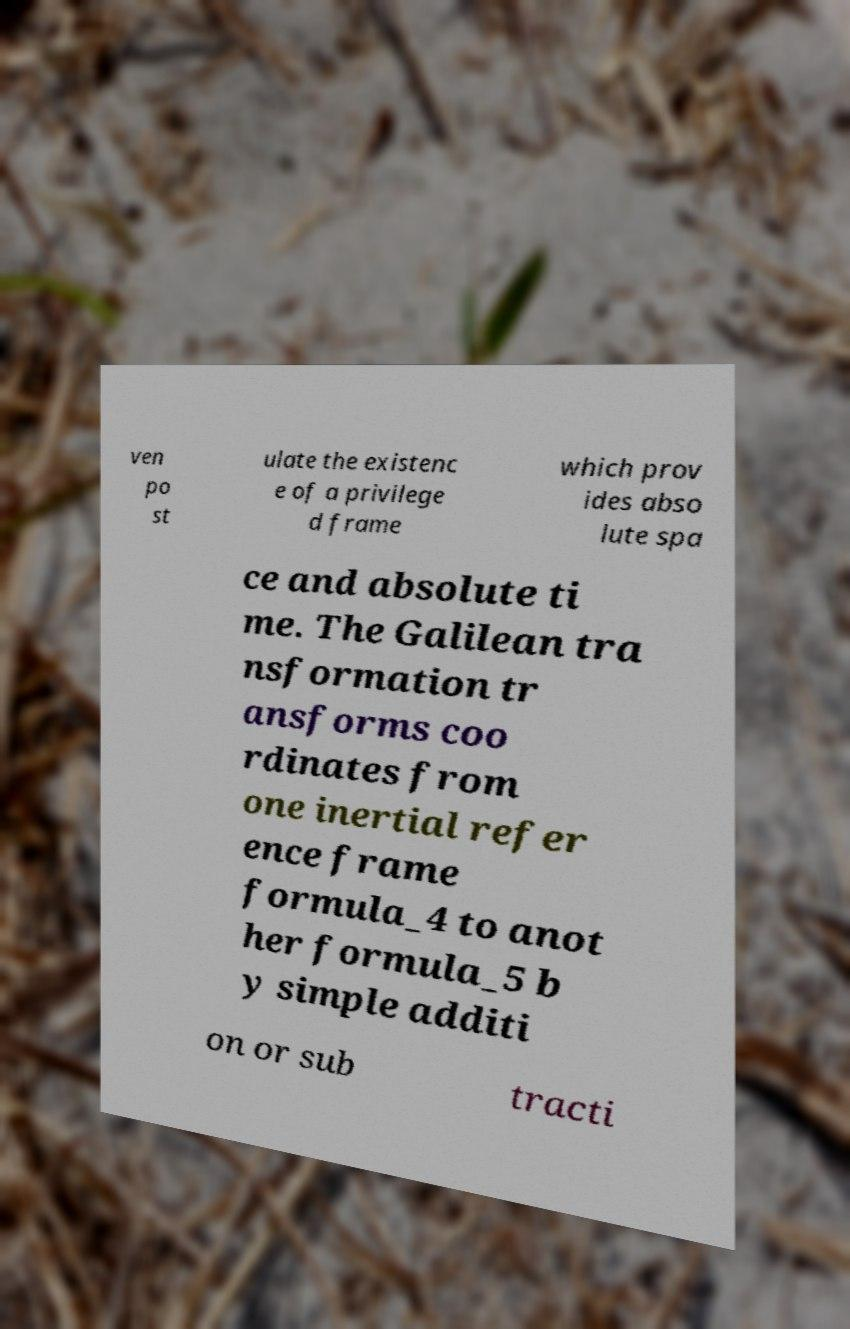What messages or text are displayed in this image? I need them in a readable, typed format. ven po st ulate the existenc e of a privilege d frame which prov ides abso lute spa ce and absolute ti me. The Galilean tra nsformation tr ansforms coo rdinates from one inertial refer ence frame formula_4 to anot her formula_5 b y simple additi on or sub tracti 